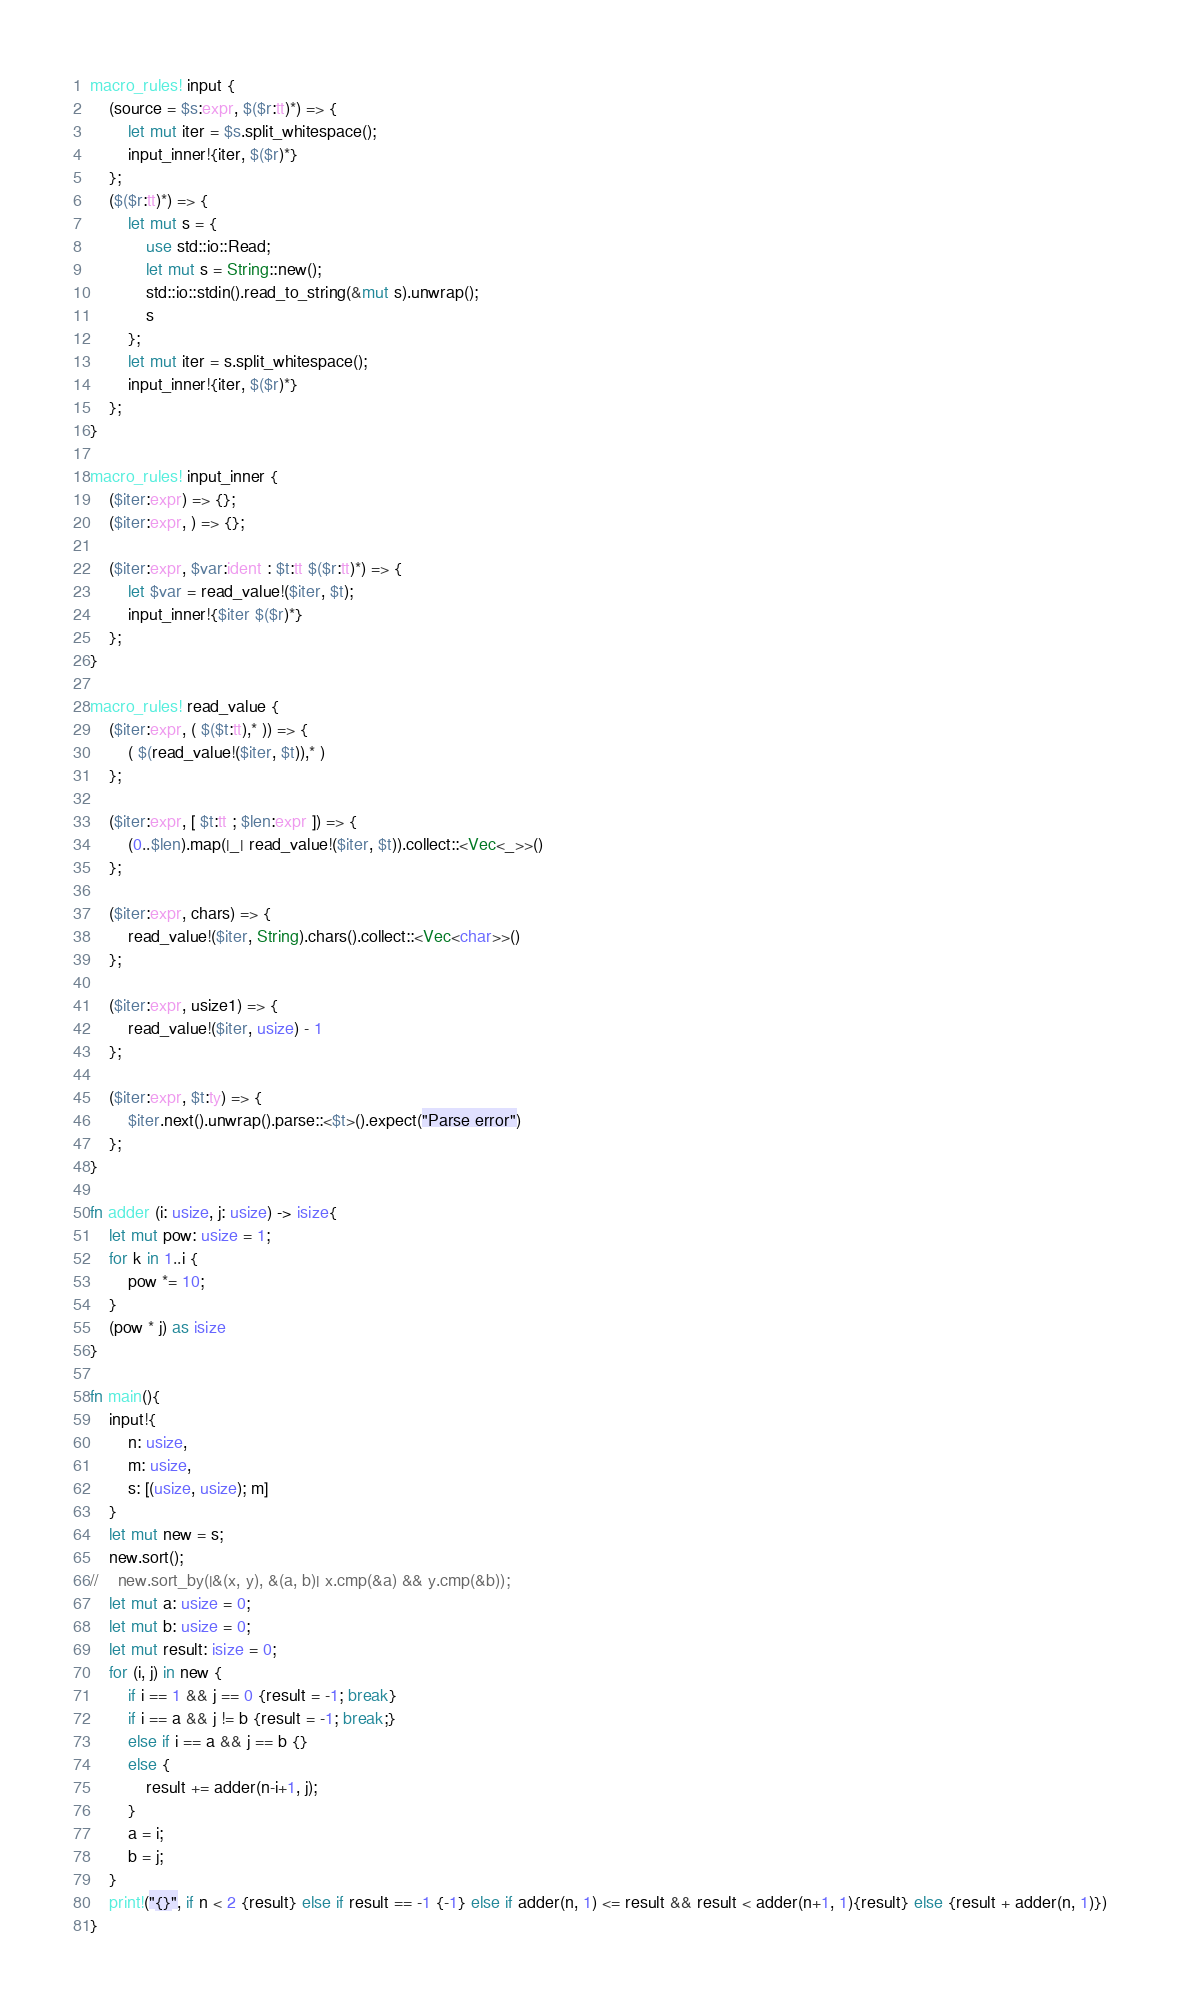Convert code to text. <code><loc_0><loc_0><loc_500><loc_500><_Rust_>macro_rules! input {
    (source = $s:expr, $($r:tt)*) => {
        let mut iter = $s.split_whitespace();
        input_inner!{iter, $($r)*}
    };
    ($($r:tt)*) => {
        let mut s = {
            use std::io::Read;
            let mut s = String::new();
            std::io::stdin().read_to_string(&mut s).unwrap();
            s
        };
        let mut iter = s.split_whitespace();
        input_inner!{iter, $($r)*}
    };
}

macro_rules! input_inner {
    ($iter:expr) => {};
    ($iter:expr, ) => {};

    ($iter:expr, $var:ident : $t:tt $($r:tt)*) => {
        let $var = read_value!($iter, $t);
        input_inner!{$iter $($r)*}
    };
}

macro_rules! read_value {
    ($iter:expr, ( $($t:tt),* )) => {
        ( $(read_value!($iter, $t)),* )
    };

    ($iter:expr, [ $t:tt ; $len:expr ]) => {
        (0..$len).map(|_| read_value!($iter, $t)).collect::<Vec<_>>()
    };

    ($iter:expr, chars) => {
        read_value!($iter, String).chars().collect::<Vec<char>>()
    };

    ($iter:expr, usize1) => {
        read_value!($iter, usize) - 1
    };

    ($iter:expr, $t:ty) => {
        $iter.next().unwrap().parse::<$t>().expect("Parse error")
    };
}

fn adder (i: usize, j: usize) -> isize{
    let mut pow: usize = 1;
    for k in 1..i {
        pow *= 10;
    }
    (pow * j) as isize
}

fn main(){
    input!{
        n: usize,
        m: usize,
        s: [(usize, usize); m]
    }
    let mut new = s;
    new.sort();
//    new.sort_by(|&(x, y), &(a, b)| x.cmp(&a) && y.cmp(&b));
    let mut a: usize = 0;
    let mut b: usize = 0;
    let mut result: isize = 0;
    for (i, j) in new {
        if i == 1 && j == 0 {result = -1; break}
        if i == a && j != b {result = -1; break;}
        else if i == a && j == b {}
        else {
            result += adder(n-i+1, j);
        }
        a = i;
        b = j;
    }
    print!("{}", if n < 2 {result} else if result == -1 {-1} else if adder(n, 1) <= result && result < adder(n+1, 1){result} else {result + adder(n, 1)})
}
</code> 